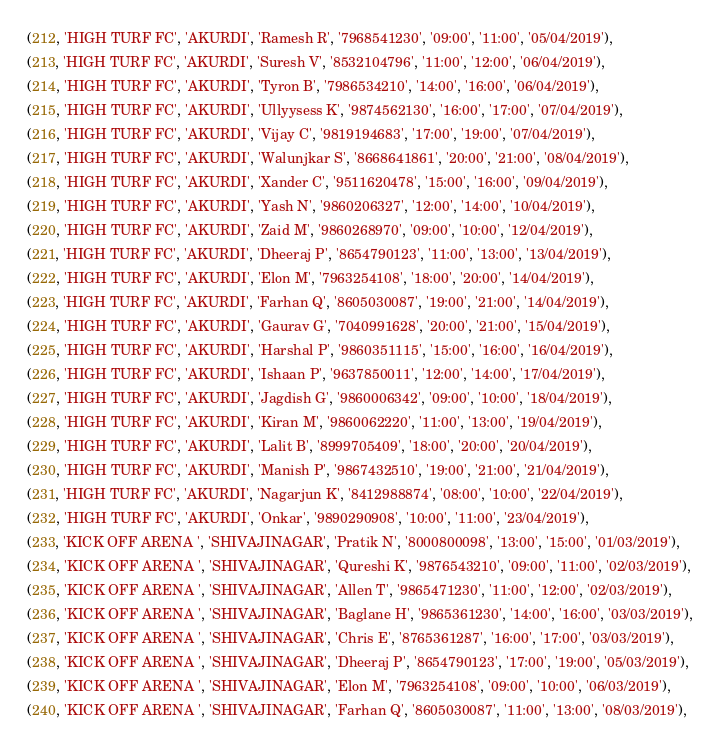<code> <loc_0><loc_0><loc_500><loc_500><_SQL_>(212, 'HIGH TURF FC', 'AKURDI', 'Ramesh R', '7968541230', '09:00', '11:00', '05/04/2019'),
(213, 'HIGH TURF FC', 'AKURDI', 'Suresh V', '8532104796', '11:00', '12:00', '06/04/2019'),
(214, 'HIGH TURF FC', 'AKURDI', 'Tyron B', '7986534210', '14:00', '16:00', '06/04/2019'),
(215, 'HIGH TURF FC', 'AKURDI', 'Ullyysess K', '9874562130', '16:00', '17:00', '07/04/2019'),
(216, 'HIGH TURF FC', 'AKURDI', 'Vijay C', '9819194683', '17:00', '19:00', '07/04/2019'),
(217, 'HIGH TURF FC', 'AKURDI', 'Walunjkar S', '8668641861', '20:00', '21:00', '08/04/2019'),
(218, 'HIGH TURF FC', 'AKURDI', 'Xander C', '9511620478', '15:00', '16:00', '09/04/2019'),
(219, 'HIGH TURF FC', 'AKURDI', 'Yash N', '9860206327', '12:00', '14:00', '10/04/2019'),
(220, 'HIGH TURF FC', 'AKURDI', 'Zaid M', '9860268970', '09:00', '10:00', '12/04/2019'),
(221, 'HIGH TURF FC', 'AKURDI', 'Dheeraj P', '8654790123', '11:00', '13:00', '13/04/2019'),
(222, 'HIGH TURF FC', 'AKURDI', 'Elon M', '7963254108', '18:00', '20:00', '14/04/2019'),
(223, 'HIGH TURF FC', 'AKURDI', 'Farhan Q', '8605030087', '19:00', '21:00', '14/04/2019'),
(224, 'HIGH TURF FC', 'AKURDI', 'Gaurav G', '7040991628', '20:00', '21:00', '15/04/2019'),
(225, 'HIGH TURF FC', 'AKURDI', 'Harshal P', '9860351115', '15:00', '16:00', '16/04/2019'),
(226, 'HIGH TURF FC', 'AKURDI', 'Ishaan P', '9637850011', '12:00', '14:00', '17/04/2019'),
(227, 'HIGH TURF FC', 'AKURDI', 'Jagdish G', '9860006342', '09:00', '10:00', '18/04/2019'),
(228, 'HIGH TURF FC', 'AKURDI', 'Kiran M', '9860062220', '11:00', '13:00', '19/04/2019'),
(229, 'HIGH TURF FC', 'AKURDI', 'Lalit B', '8999705409', '18:00', '20:00', '20/04/2019'),
(230, 'HIGH TURF FC', 'AKURDI', 'Manish P', '9867432510', '19:00', '21:00', '21/04/2019'),
(231, 'HIGH TURF FC', 'AKURDI', 'Nagarjun K', '8412988874', '08:00', '10:00', '22/04/2019'),
(232, 'HIGH TURF FC', 'AKURDI', 'Onkar', '9890290908', '10:00', '11:00', '23/04/2019'),
(233, 'KICK OFF ARENA ', 'SHIVAJINAGAR', 'Pratik N', '8000800098', '13:00', '15:00', '01/03/2019'),
(234, 'KICK OFF ARENA ', 'SHIVAJINAGAR', 'Qureshi K', '9876543210', '09:00', '11:00', '02/03/2019'),
(235, 'KICK OFF ARENA ', 'SHIVAJINAGAR', 'Allen T', '9865471230', '11:00', '12:00', '02/03/2019'),
(236, 'KICK OFF ARENA ', 'SHIVAJINAGAR', 'Baglane H', '9865361230', '14:00', '16:00', '03/03/2019'),
(237, 'KICK OFF ARENA ', 'SHIVAJINAGAR', 'Chris E', '8765361287', '16:00', '17:00', '03/03/2019'),
(238, 'KICK OFF ARENA ', 'SHIVAJINAGAR', 'Dheeraj P', '8654790123', '17:00', '19:00', '05/03/2019'),
(239, 'KICK OFF ARENA ', 'SHIVAJINAGAR', 'Elon M', '7963254108', '09:00', '10:00', '06/03/2019'),
(240, 'KICK OFF ARENA ', 'SHIVAJINAGAR', 'Farhan Q', '8605030087', '11:00', '13:00', '08/03/2019'),</code> 